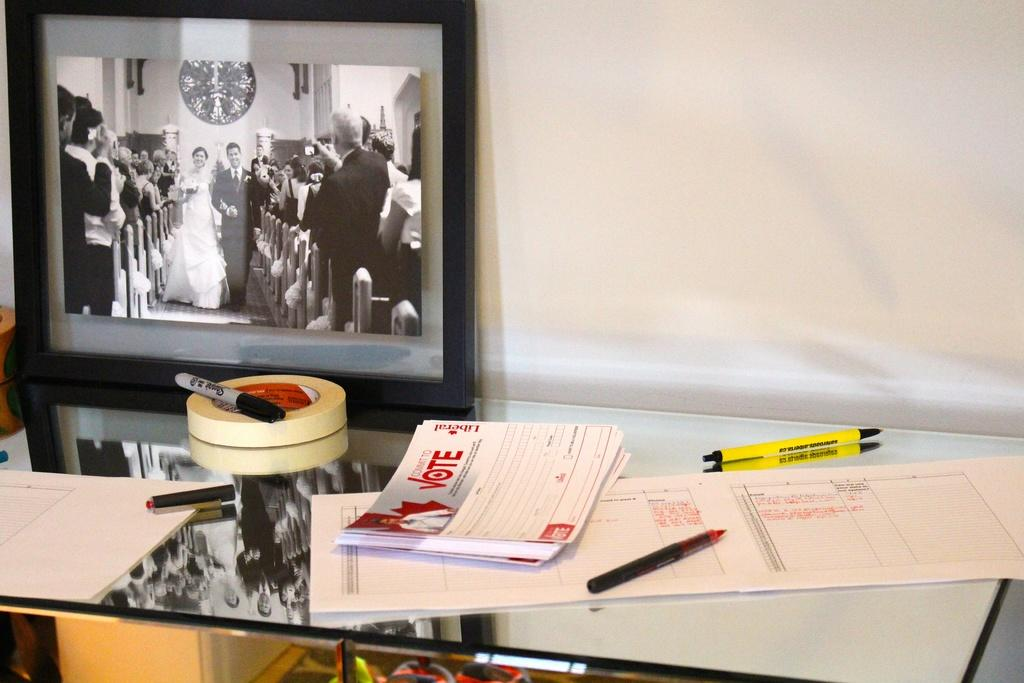What object in the image allows for reflection? There is a mirror in the image. What items are placed on the mirror? Papers, books, pens, and a tape are visible on the mirror. What is present on the wall in the image? There is a frame on the wall. What can be seen in the mirror's reflection? The reflection of the frame is visible in the mirror. What title does the stranger give to the artwork in the image? There is no stranger present in the image, and therefore no title can be given to any artwork. What type of spoon is used to stir the tea in the image? There is no tea or spoon present in the image. 